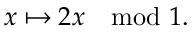Convert formula to latex. <formula><loc_0><loc_0><loc_500><loc_500>x \mapsto 2 x \mod 1 .</formula> 